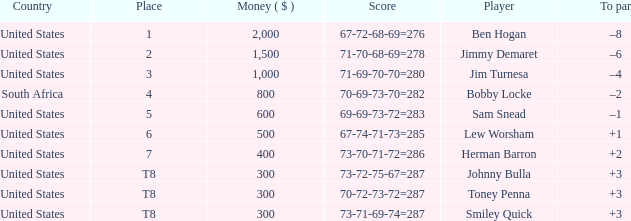What is the Place of the Player with a To par of –1? 5.0. 